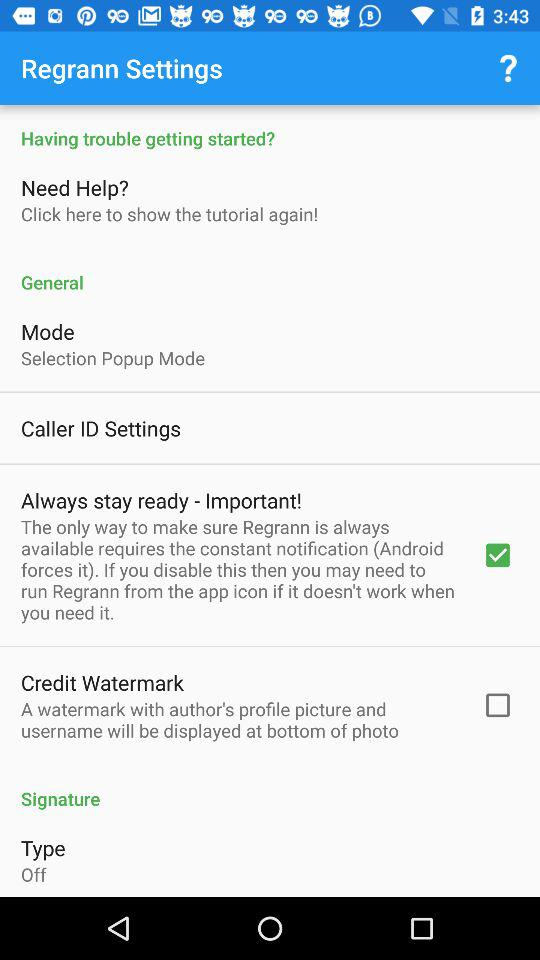What is the status of "Always stay ready - Important!"? The status is "on". 